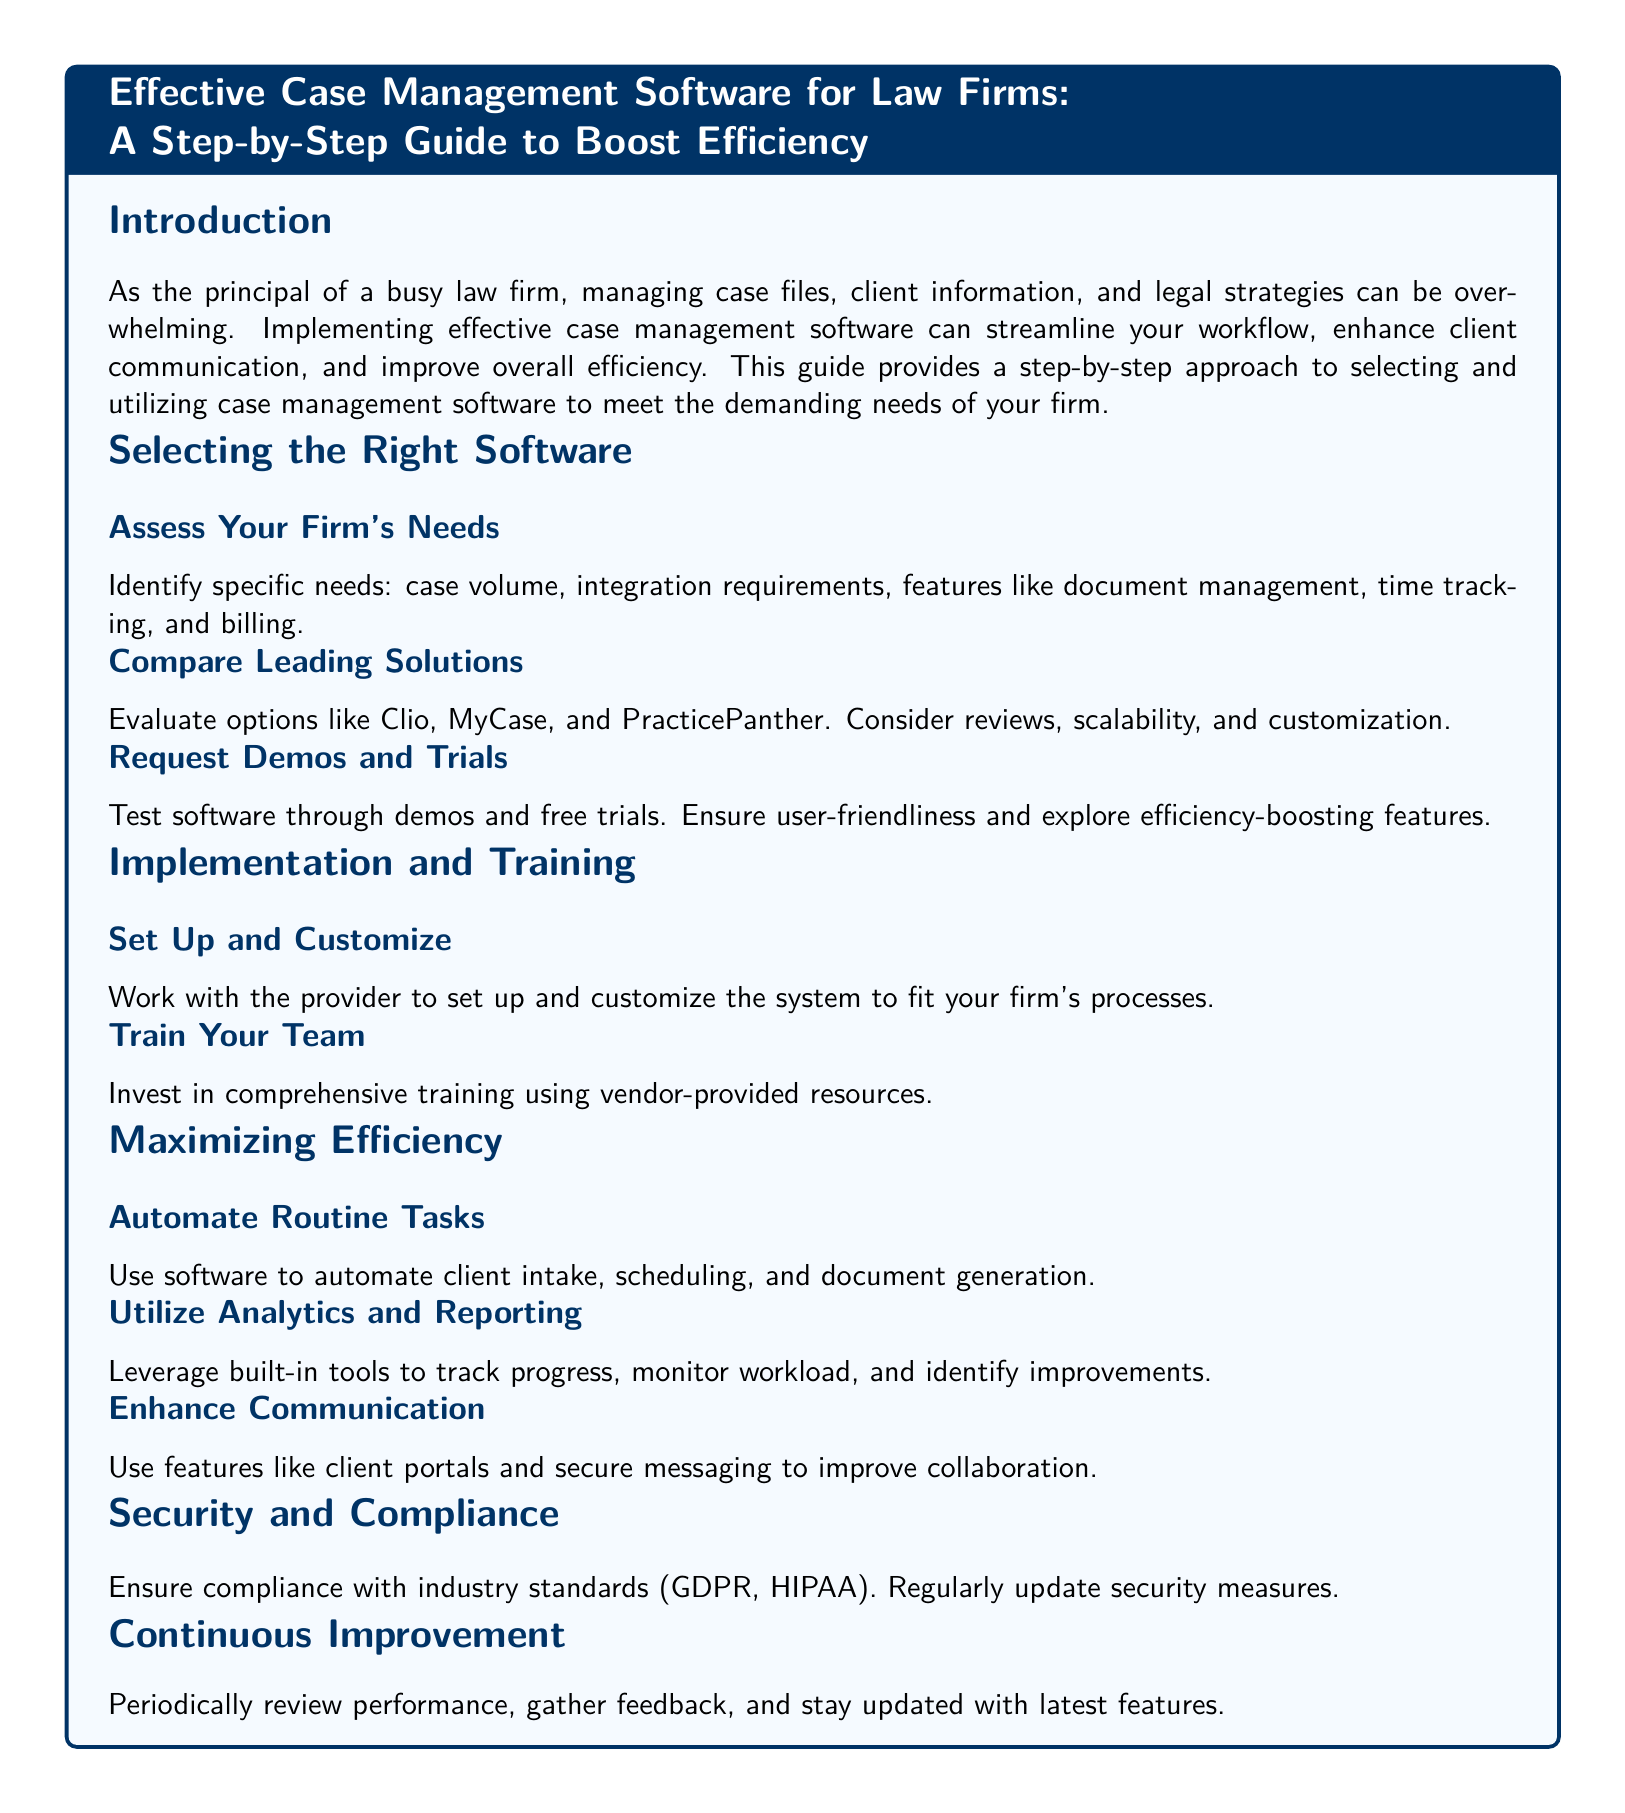What is the title of the guide? The title of the guide is specified at the top, summarizing its purpose and audience.
Answer: Effective Case Management Software for Law Firms: A Step-by-Step Guide to Boost Efficiency How should a law firm assess their needs? The guide specifies that firms should identify specific needs such as case volume and integration requirements.
Answer: Assess Your Firm's Needs What are three software options mentioned? The guide lists options to consider for case management software.
Answer: Clio, MyCase, PracticePanther What is a key benefit of automating routine tasks? The guide emphasizes the efficiency gained from automating administrative work.
Answer: Boost efficiency What should be ensured for security and compliance? The guide points out the need to comply with industry standards for security.
Answer: Compliance with industry standards What is advised for team training? The guide recommends investing in training for effective software use.
Answer: Comprehensive training How often should performance be reviewed? The guide highlights the importance of periodic reviews for continuous improvement.
Answer: Periodically What is a feature that enhances communication? The guide suggests using specific tools to improve collaboration with clients.
Answer: Client portals and secure messaging 